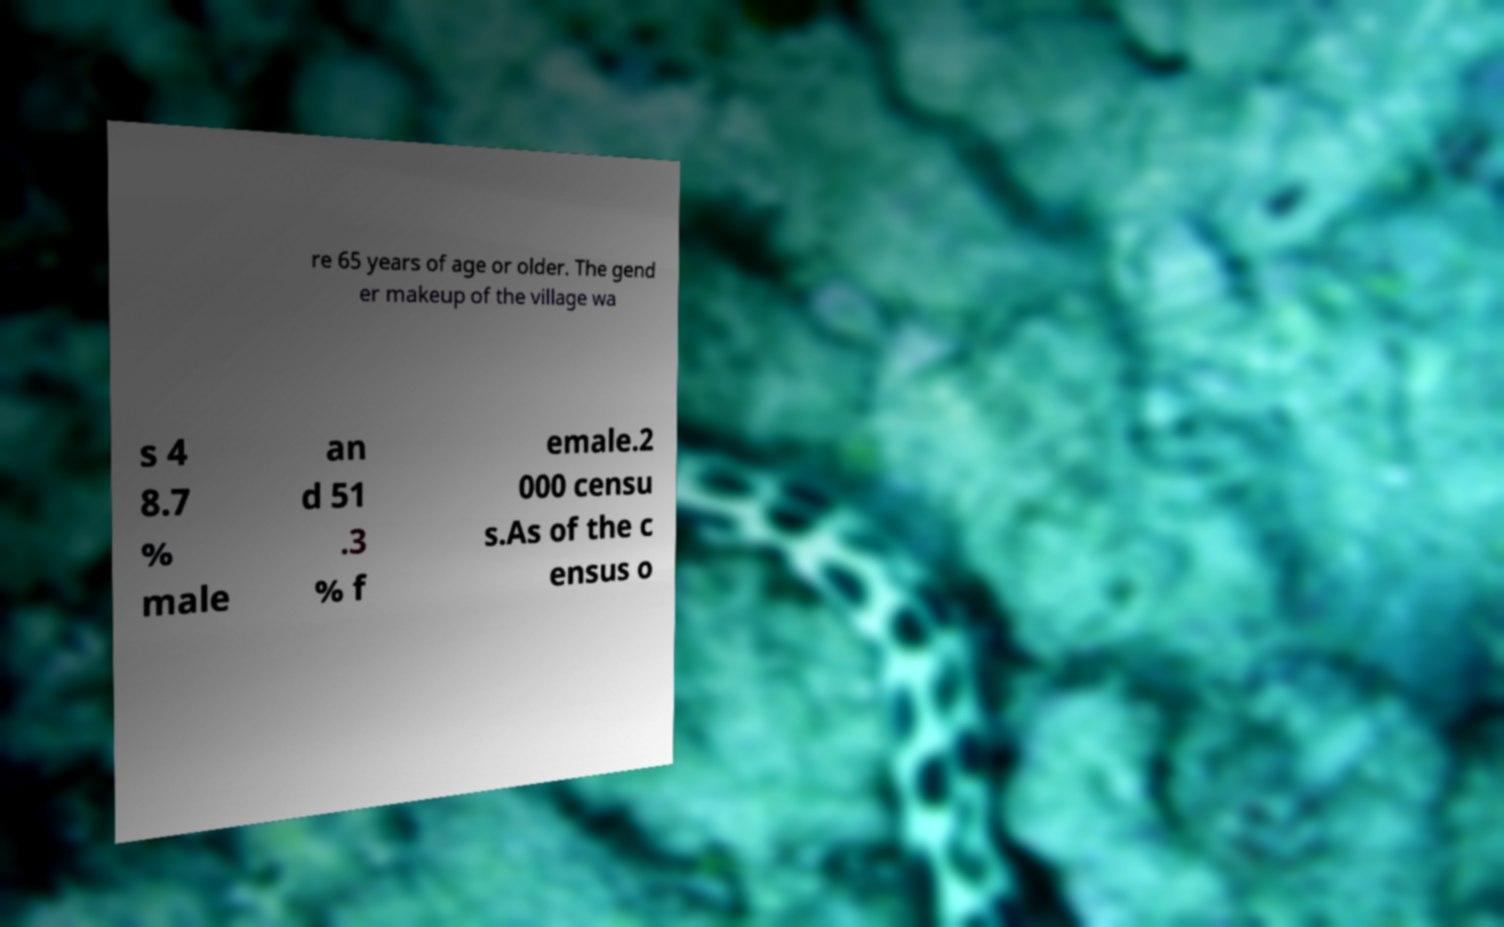What messages or text are displayed in this image? I need them in a readable, typed format. re 65 years of age or older. The gend er makeup of the village wa s 4 8.7 % male an d 51 .3 % f emale.2 000 censu s.As of the c ensus o 